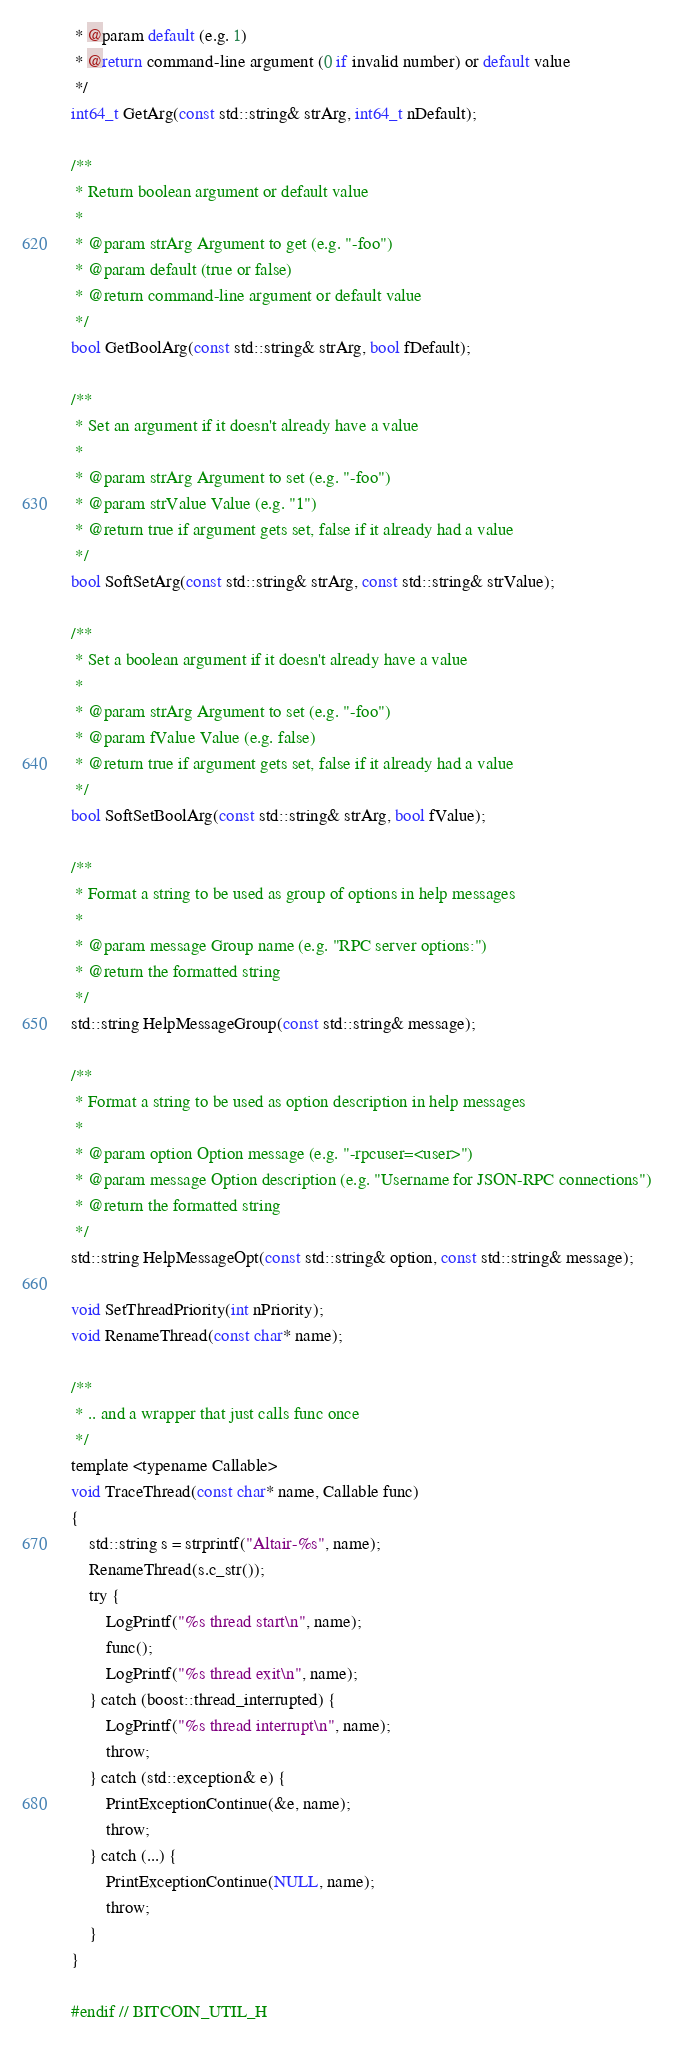<code> <loc_0><loc_0><loc_500><loc_500><_C_> * @param default (e.g. 1)
 * @return command-line argument (0 if invalid number) or default value
 */
int64_t GetArg(const std::string& strArg, int64_t nDefault);

/**
 * Return boolean argument or default value
 *
 * @param strArg Argument to get (e.g. "-foo")
 * @param default (true or false)
 * @return command-line argument or default value
 */
bool GetBoolArg(const std::string& strArg, bool fDefault);

/**
 * Set an argument if it doesn't already have a value
 *
 * @param strArg Argument to set (e.g. "-foo")
 * @param strValue Value (e.g. "1")
 * @return true if argument gets set, false if it already had a value
 */
bool SoftSetArg(const std::string& strArg, const std::string& strValue);

/**
 * Set a boolean argument if it doesn't already have a value
 *
 * @param strArg Argument to set (e.g. "-foo")
 * @param fValue Value (e.g. false)
 * @return true if argument gets set, false if it already had a value
 */
bool SoftSetBoolArg(const std::string& strArg, bool fValue);

/**
 * Format a string to be used as group of options in help messages
 *
 * @param message Group name (e.g. "RPC server options:")
 * @return the formatted string
 */
std::string HelpMessageGroup(const std::string& message);

/**
 * Format a string to be used as option description in help messages
 *
 * @param option Option message (e.g. "-rpcuser=<user>")
 * @param message Option description (e.g. "Username for JSON-RPC connections")
 * @return the formatted string
 */
std::string HelpMessageOpt(const std::string& option, const std::string& message);

void SetThreadPriority(int nPriority);
void RenameThread(const char* name);

/**
 * .. and a wrapper that just calls func once
 */
template <typename Callable>
void TraceThread(const char* name, Callable func)
{
    std::string s = strprintf("Altair-%s", name);
    RenameThread(s.c_str());
    try {
        LogPrintf("%s thread start\n", name);
        func();
        LogPrintf("%s thread exit\n", name);
    } catch (boost::thread_interrupted) {
        LogPrintf("%s thread interrupt\n", name);
        throw;
    } catch (std::exception& e) {
        PrintExceptionContinue(&e, name);
        throw;
    } catch (...) {
        PrintExceptionContinue(NULL, name);
        throw;
    }
}

#endif // BITCOIN_UTIL_H
</code> 